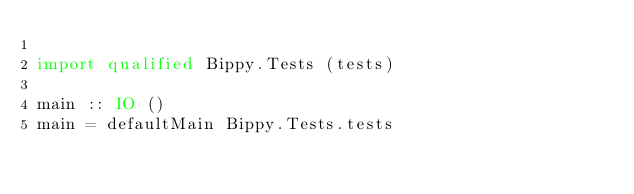Convert code to text. <code><loc_0><loc_0><loc_500><loc_500><_Haskell_>
import qualified Bippy.Tests (tests)

main :: IO ()
main = defaultMain Bippy.Tests.tests
</code> 